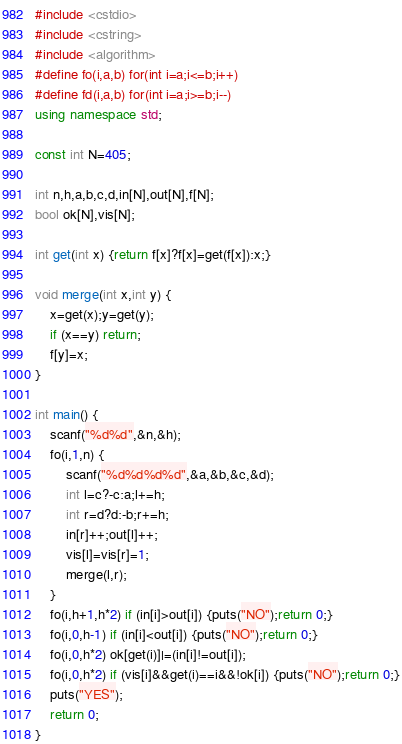Convert code to text. <code><loc_0><loc_0><loc_500><loc_500><_C++_>#include <cstdio>
#include <cstring>
#include <algorithm>
#define fo(i,a,b) for(int i=a;i<=b;i++)
#define fd(i,a,b) for(int i=a;i>=b;i--)
using namespace std;

const int N=405;

int n,h,a,b,c,d,in[N],out[N],f[N];
bool ok[N],vis[N];

int get(int x) {return f[x]?f[x]=get(f[x]):x;}

void merge(int x,int y) {
	x=get(x);y=get(y);
	if (x==y) return;
	f[y]=x;
}

int main() {
	scanf("%d%d",&n,&h);
	fo(i,1,n) {
		scanf("%d%d%d%d",&a,&b,&c,&d);
		int l=c?-c:a;l+=h;
		int r=d?d:-b;r+=h;
		in[r]++;out[l]++;
		vis[l]=vis[r]=1;
		merge(l,r);
	}
	fo(i,h+1,h*2) if (in[i]>out[i]) {puts("NO");return 0;}
	fo(i,0,h-1) if (in[i]<out[i]) {puts("NO");return 0;}
	fo(i,0,h*2) ok[get(i)]|=(in[i]!=out[i]);
	fo(i,0,h*2) if (vis[i]&&get(i)==i&&!ok[i]) {puts("NO");return 0;}
	puts("YES");
	return 0;
}</code> 